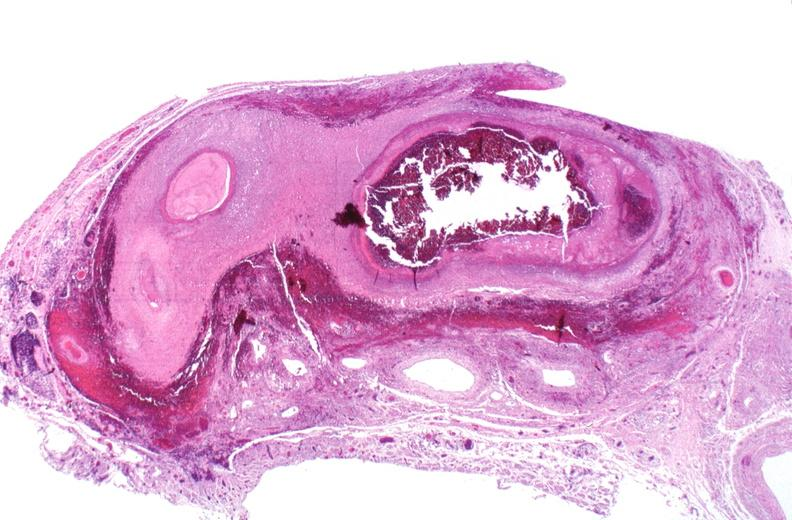what does this image show?
Answer the question using a single word or phrase. Polyarteritis nodosa 